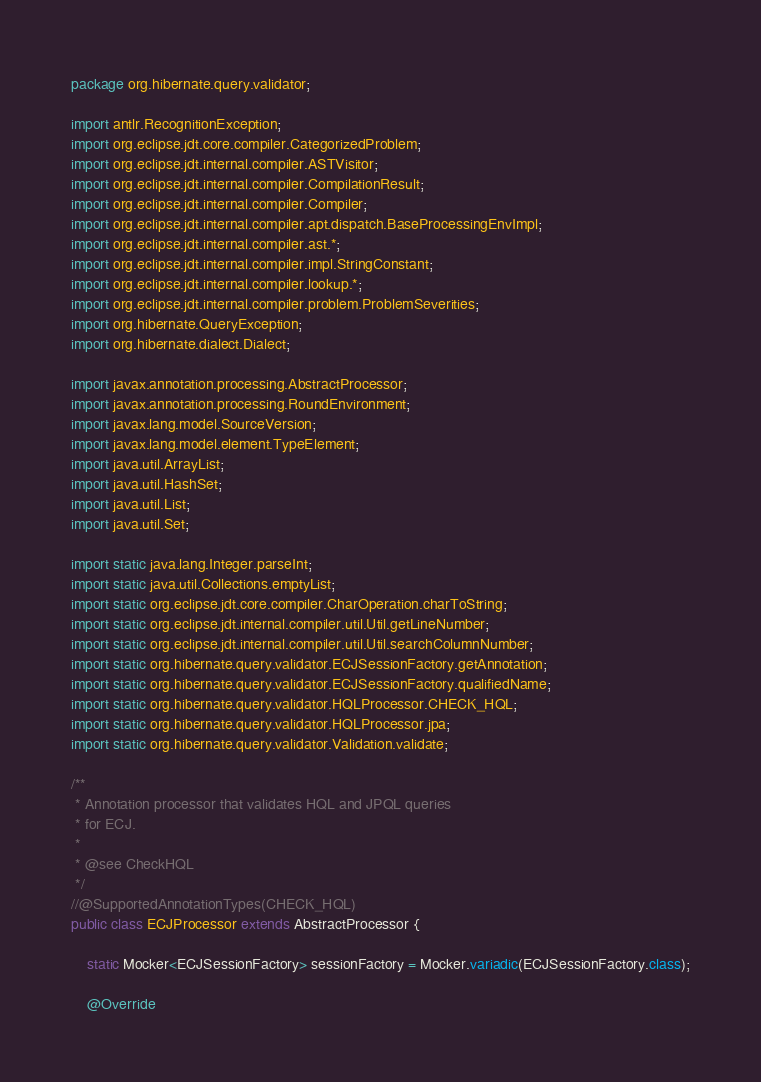<code> <loc_0><loc_0><loc_500><loc_500><_Java_>package org.hibernate.query.validator;

import antlr.RecognitionException;
import org.eclipse.jdt.core.compiler.CategorizedProblem;
import org.eclipse.jdt.internal.compiler.ASTVisitor;
import org.eclipse.jdt.internal.compiler.CompilationResult;
import org.eclipse.jdt.internal.compiler.Compiler;
import org.eclipse.jdt.internal.compiler.apt.dispatch.BaseProcessingEnvImpl;
import org.eclipse.jdt.internal.compiler.ast.*;
import org.eclipse.jdt.internal.compiler.impl.StringConstant;
import org.eclipse.jdt.internal.compiler.lookup.*;
import org.eclipse.jdt.internal.compiler.problem.ProblemSeverities;
import org.hibernate.QueryException;
import org.hibernate.dialect.Dialect;

import javax.annotation.processing.AbstractProcessor;
import javax.annotation.processing.RoundEnvironment;
import javax.lang.model.SourceVersion;
import javax.lang.model.element.TypeElement;
import java.util.ArrayList;
import java.util.HashSet;
import java.util.List;
import java.util.Set;

import static java.lang.Integer.parseInt;
import static java.util.Collections.emptyList;
import static org.eclipse.jdt.core.compiler.CharOperation.charToString;
import static org.eclipse.jdt.internal.compiler.util.Util.getLineNumber;
import static org.eclipse.jdt.internal.compiler.util.Util.searchColumnNumber;
import static org.hibernate.query.validator.ECJSessionFactory.getAnnotation;
import static org.hibernate.query.validator.ECJSessionFactory.qualifiedName;
import static org.hibernate.query.validator.HQLProcessor.CHECK_HQL;
import static org.hibernate.query.validator.HQLProcessor.jpa;
import static org.hibernate.query.validator.Validation.validate;

/**
 * Annotation processor that validates HQL and JPQL queries
 * for ECJ.
 *
 * @see CheckHQL
 */
//@SupportedAnnotationTypes(CHECK_HQL)
public class ECJProcessor extends AbstractProcessor {

    static Mocker<ECJSessionFactory> sessionFactory = Mocker.variadic(ECJSessionFactory.class);

    @Override</code> 